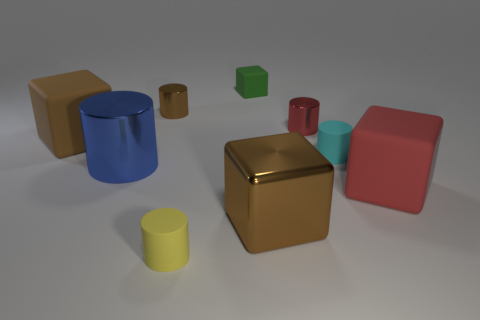Subtract all tiny red cylinders. How many cylinders are left? 4 Subtract all brown cylinders. How many cylinders are left? 4 Subtract all gray blocks. Subtract all brown cylinders. How many blocks are left? 4 Add 1 balls. How many objects exist? 10 Subtract all cubes. How many objects are left? 5 Add 1 shiny cylinders. How many shiny cylinders exist? 4 Subtract 0 purple balls. How many objects are left? 9 Subtract all big matte objects. Subtract all green things. How many objects are left? 6 Add 3 big blue metallic things. How many big blue metallic things are left? 4 